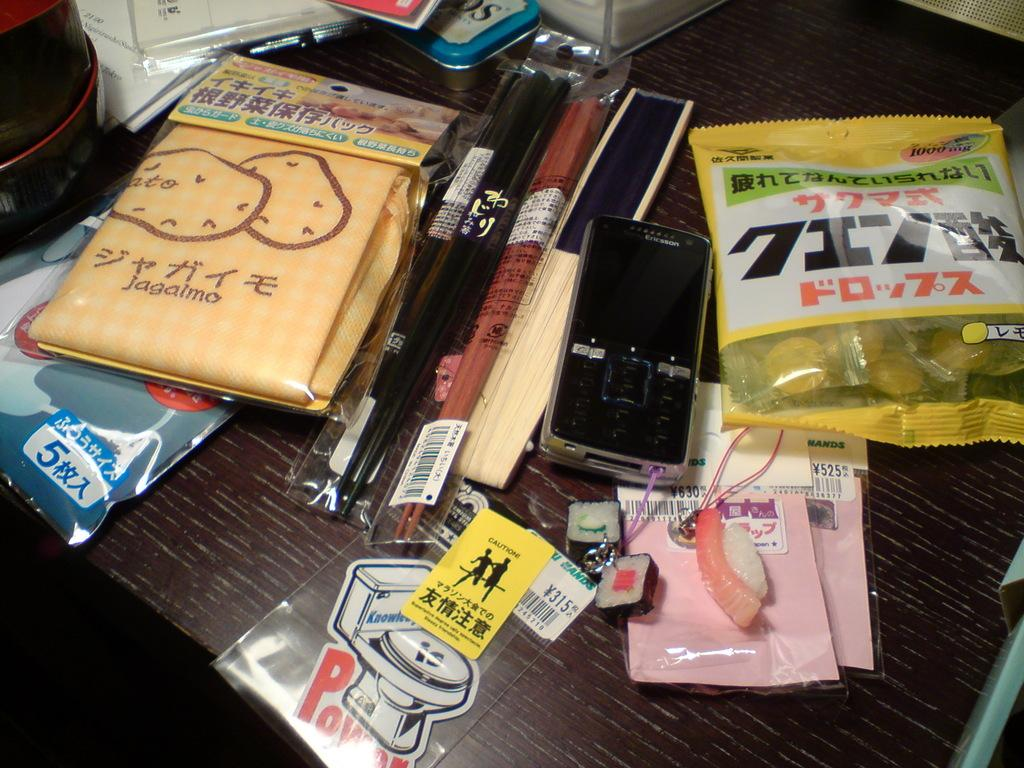<image>
Provide a brief description of the given image. Some chopsticks in plastic covers lay on a desk top with other items and one of them being an Ericsson cell phone. 